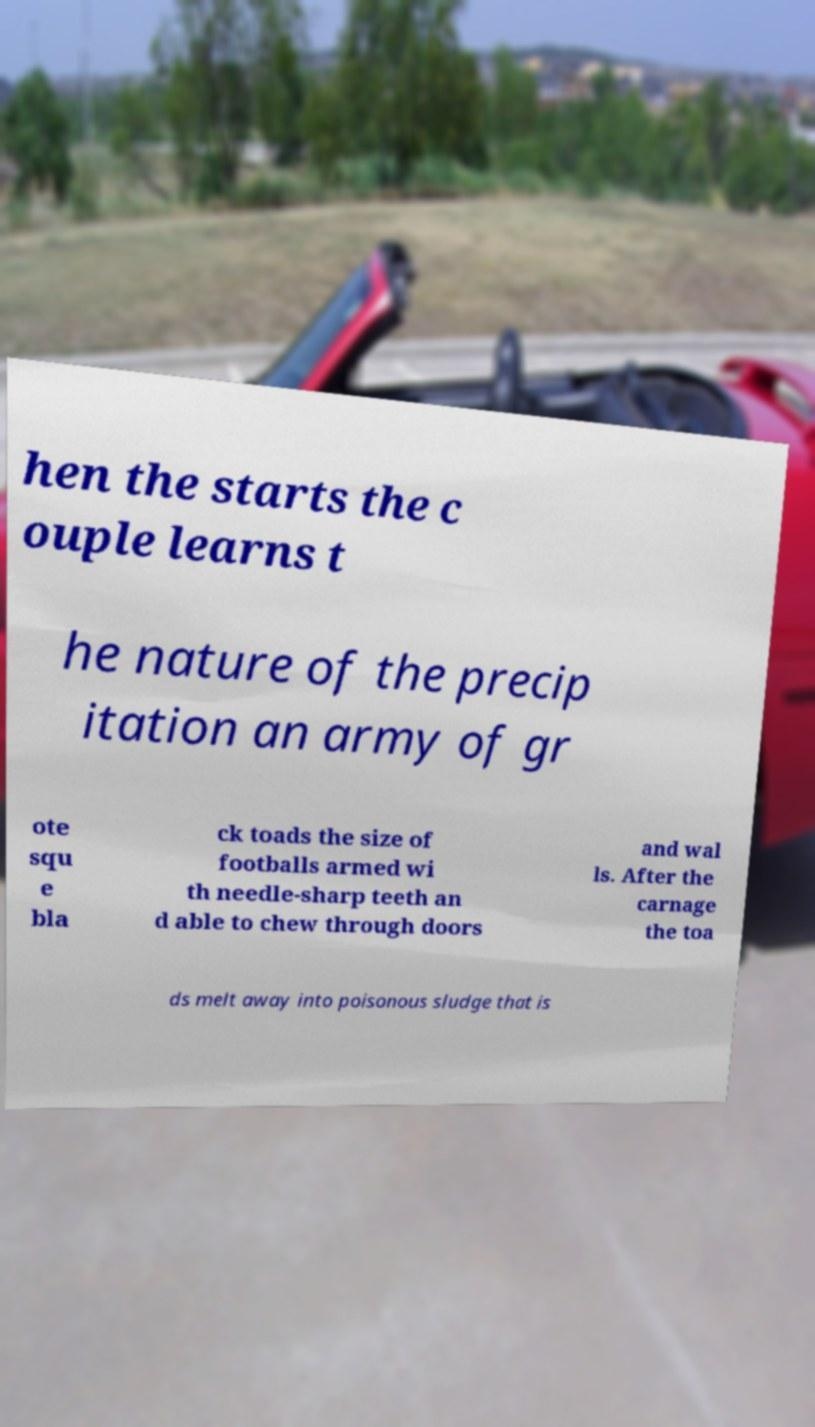Can you read and provide the text displayed in the image?This photo seems to have some interesting text. Can you extract and type it out for me? hen the starts the c ouple learns t he nature of the precip itation an army of gr ote squ e bla ck toads the size of footballs armed wi th needle-sharp teeth an d able to chew through doors and wal ls. After the carnage the toa ds melt away into poisonous sludge that is 